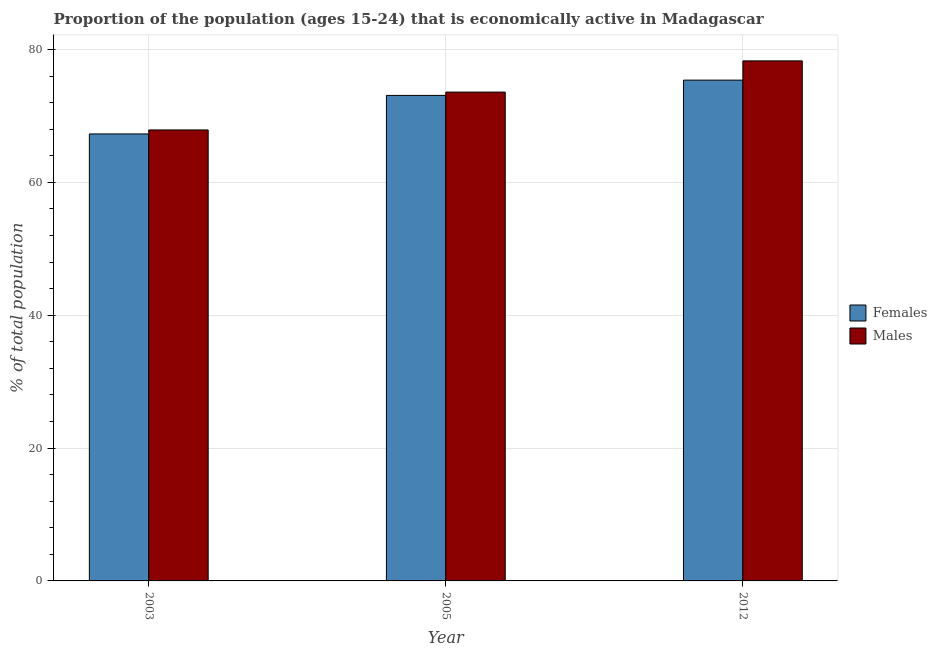How many groups of bars are there?
Your response must be concise. 3. How many bars are there on the 1st tick from the left?
Your response must be concise. 2. How many bars are there on the 2nd tick from the right?
Provide a short and direct response. 2. What is the percentage of economically active male population in 2005?
Keep it short and to the point. 73.6. Across all years, what is the maximum percentage of economically active male population?
Ensure brevity in your answer.  78.3. Across all years, what is the minimum percentage of economically active male population?
Keep it short and to the point. 67.9. In which year was the percentage of economically active male population minimum?
Provide a succinct answer. 2003. What is the total percentage of economically active female population in the graph?
Ensure brevity in your answer.  215.8. What is the difference between the percentage of economically active male population in 2003 and that in 2012?
Your answer should be very brief. -10.4. What is the difference between the percentage of economically active female population in 2005 and the percentage of economically active male population in 2003?
Keep it short and to the point. 5.8. What is the average percentage of economically active male population per year?
Make the answer very short. 73.27. In how many years, is the percentage of economically active male population greater than 56 %?
Keep it short and to the point. 3. What is the ratio of the percentage of economically active female population in 2003 to that in 2005?
Make the answer very short. 0.92. What is the difference between the highest and the second highest percentage of economically active male population?
Ensure brevity in your answer.  4.7. What is the difference between the highest and the lowest percentage of economically active male population?
Your response must be concise. 10.4. What does the 1st bar from the left in 2012 represents?
Provide a succinct answer. Females. What does the 2nd bar from the right in 2005 represents?
Offer a very short reply. Females. How many bars are there?
Offer a very short reply. 6. Are all the bars in the graph horizontal?
Provide a short and direct response. No. Does the graph contain any zero values?
Ensure brevity in your answer.  No. Does the graph contain grids?
Offer a very short reply. Yes. What is the title of the graph?
Your response must be concise. Proportion of the population (ages 15-24) that is economically active in Madagascar. What is the label or title of the X-axis?
Offer a very short reply. Year. What is the label or title of the Y-axis?
Give a very brief answer. % of total population. What is the % of total population in Females in 2003?
Your answer should be compact. 67.3. What is the % of total population in Males in 2003?
Your response must be concise. 67.9. What is the % of total population of Females in 2005?
Offer a very short reply. 73.1. What is the % of total population of Males in 2005?
Ensure brevity in your answer.  73.6. What is the % of total population of Females in 2012?
Your response must be concise. 75.4. What is the % of total population of Males in 2012?
Give a very brief answer. 78.3. Across all years, what is the maximum % of total population in Females?
Keep it short and to the point. 75.4. Across all years, what is the maximum % of total population in Males?
Offer a terse response. 78.3. Across all years, what is the minimum % of total population in Females?
Your response must be concise. 67.3. Across all years, what is the minimum % of total population of Males?
Make the answer very short. 67.9. What is the total % of total population in Females in the graph?
Your response must be concise. 215.8. What is the total % of total population of Males in the graph?
Provide a succinct answer. 219.8. What is the difference between the % of total population of Females in 2005 and that in 2012?
Your answer should be compact. -2.3. What is the difference between the % of total population of Males in 2005 and that in 2012?
Your response must be concise. -4.7. What is the difference between the % of total population in Females in 2003 and the % of total population in Males in 2012?
Your answer should be compact. -11. What is the difference between the % of total population of Females in 2005 and the % of total population of Males in 2012?
Make the answer very short. -5.2. What is the average % of total population in Females per year?
Give a very brief answer. 71.93. What is the average % of total population of Males per year?
Make the answer very short. 73.27. In the year 2003, what is the difference between the % of total population in Females and % of total population in Males?
Ensure brevity in your answer.  -0.6. In the year 2005, what is the difference between the % of total population of Females and % of total population of Males?
Your answer should be compact. -0.5. What is the ratio of the % of total population of Females in 2003 to that in 2005?
Keep it short and to the point. 0.92. What is the ratio of the % of total population of Males in 2003 to that in 2005?
Offer a terse response. 0.92. What is the ratio of the % of total population of Females in 2003 to that in 2012?
Your answer should be compact. 0.89. What is the ratio of the % of total population of Males in 2003 to that in 2012?
Offer a very short reply. 0.87. What is the ratio of the % of total population in Females in 2005 to that in 2012?
Ensure brevity in your answer.  0.97. What is the difference between the highest and the second highest % of total population in Females?
Your answer should be compact. 2.3. What is the difference between the highest and the second highest % of total population in Males?
Give a very brief answer. 4.7. What is the difference between the highest and the lowest % of total population of Males?
Offer a very short reply. 10.4. 